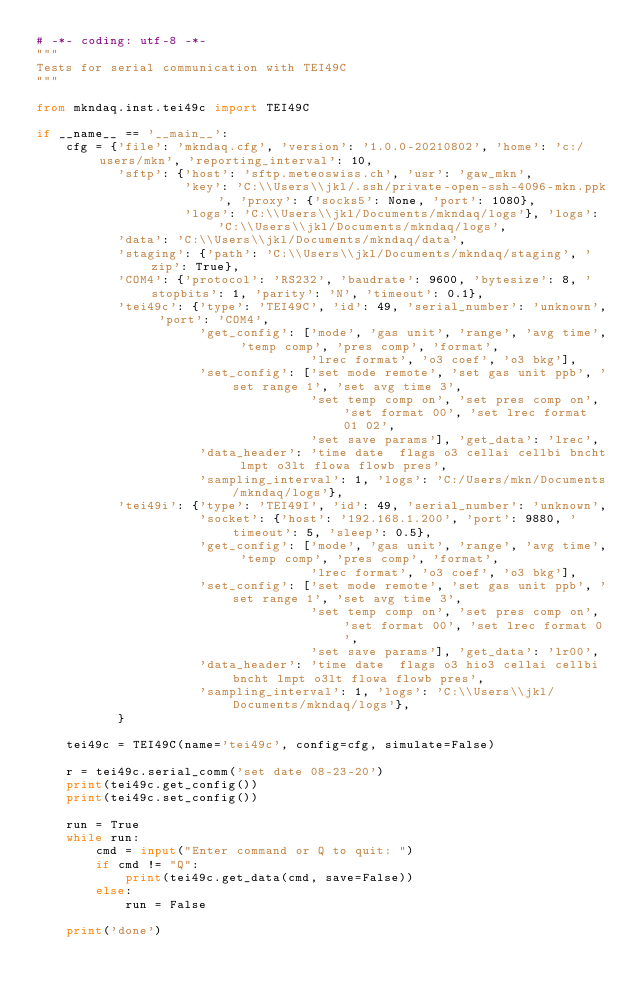<code> <loc_0><loc_0><loc_500><loc_500><_Python_># -*- coding: utf-8 -*-
"""
Tests for serial communication with TEI49C
"""

from mkndaq.inst.tei49c import TEI49C

if __name__ == '__main__':
    cfg = {'file': 'mkndaq.cfg', 'version': '1.0.0-20210802', 'home': 'c:/users/mkn', 'reporting_interval': 10,
           'sftp': {'host': 'sftp.meteoswiss.ch', 'usr': 'gaw_mkn',
                    'key': 'C:\\Users\\jkl/.ssh/private-open-ssh-4096-mkn.ppk', 'proxy': {'socks5': None, 'port': 1080},
                    'logs': 'C:\\Users\\jkl/Documents/mkndaq/logs'}, 'logs': 'C:\\Users\\jkl/Documents/mkndaq/logs',
           'data': 'C:\\Users\\jkl/Documents/mkndaq/data',
           'staging': {'path': 'C:\\Users\\jkl/Documents/mkndaq/staging', 'zip': True},
           'COM4': {'protocol': 'RS232', 'baudrate': 9600, 'bytesize': 8, 'stopbits': 1, 'parity': 'N', 'timeout': 0.1},
           'tei49c': {'type': 'TEI49C', 'id': 49, 'serial_number': 'unknown', 'port': 'COM4',
                      'get_config': ['mode', 'gas unit', 'range', 'avg time', 'temp comp', 'pres comp', 'format',
                                     'lrec format', 'o3 coef', 'o3 bkg'],
                      'set_config': ['set mode remote', 'set gas unit ppb', 'set range 1', 'set avg time 3',
                                     'set temp comp on', 'set pres comp on', 'set format 00', 'set lrec format 01 02',
                                     'set save params'], 'get_data': 'lrec',
                      'data_header': 'time date  flags o3 cellai cellbi bncht lmpt o3lt flowa flowb pres',
                      'sampling_interval': 1, 'logs': 'C:/Users/mkn/Documents/mkndaq/logs'},
           'tei49i': {'type': 'TEI49I', 'id': 49, 'serial_number': 'unknown',
                      'socket': {'host': '192.168.1.200', 'port': 9880, 'timeout': 5, 'sleep': 0.5},
                      'get_config': ['mode', 'gas unit', 'range', 'avg time', 'temp comp', 'pres comp', 'format',
                                     'lrec format', 'o3 coef', 'o3 bkg'],
                      'set_config': ['set mode remote', 'set gas unit ppb', 'set range 1', 'set avg time 3',
                                     'set temp comp on', 'set pres comp on', 'set format 00', 'set lrec format 0',
                                     'set save params'], 'get_data': 'lr00',
                      'data_header': 'time date  flags o3 hio3 cellai cellbi bncht lmpt o3lt flowa flowb pres',
                      'sampling_interval': 1, 'logs': 'C:\\Users\\jkl/Documents/mkndaq/logs'},
           }

    tei49c = TEI49C(name='tei49c', config=cfg, simulate=False)

    r = tei49c.serial_comm('set date 08-23-20')
    print(tei49c.get_config())
    print(tei49c.set_config())

    run = True
    while run:
        cmd = input("Enter command or Q to quit: ")
        if cmd != "Q":
            print(tei49c.get_data(cmd, save=False))
        else:
            run = False

    print('done')
</code> 